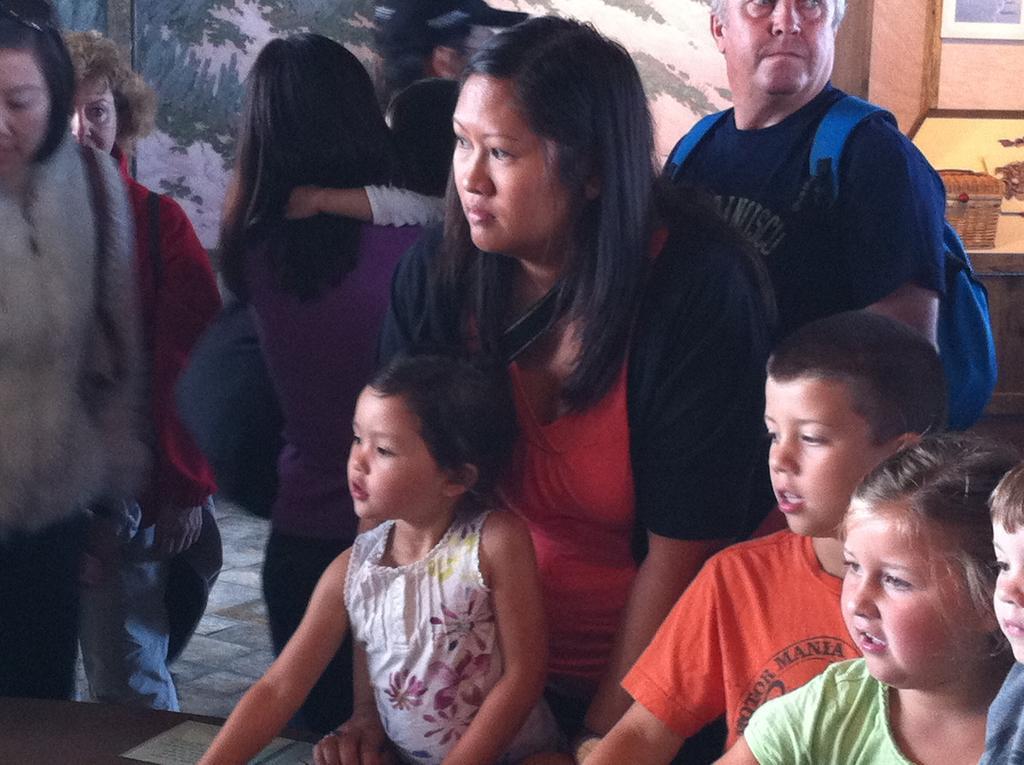Describe this image in one or two sentences. Group of people are highlighted in this picture. The red t-shirt and black jacket woman is staring, she is holding a baby. Backside of this woman, the man is carrying a bag. 